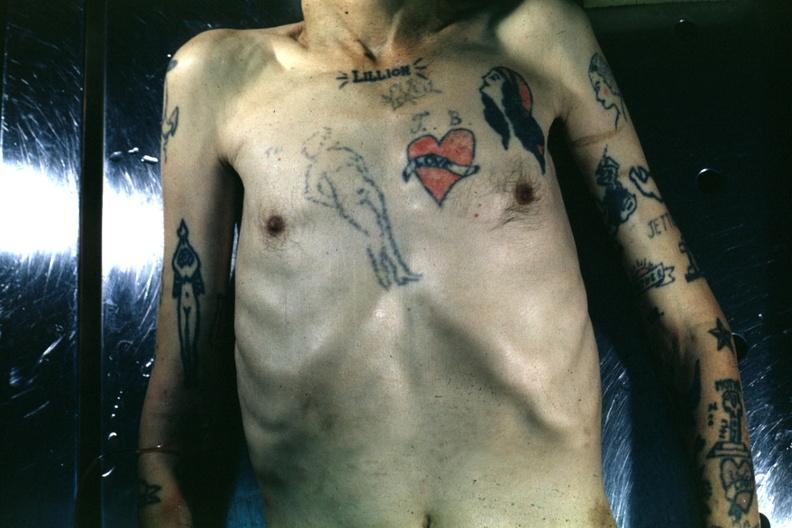does this image show upper portion of body with many tattoos?
Answer the question using a single word or phrase. Yes 